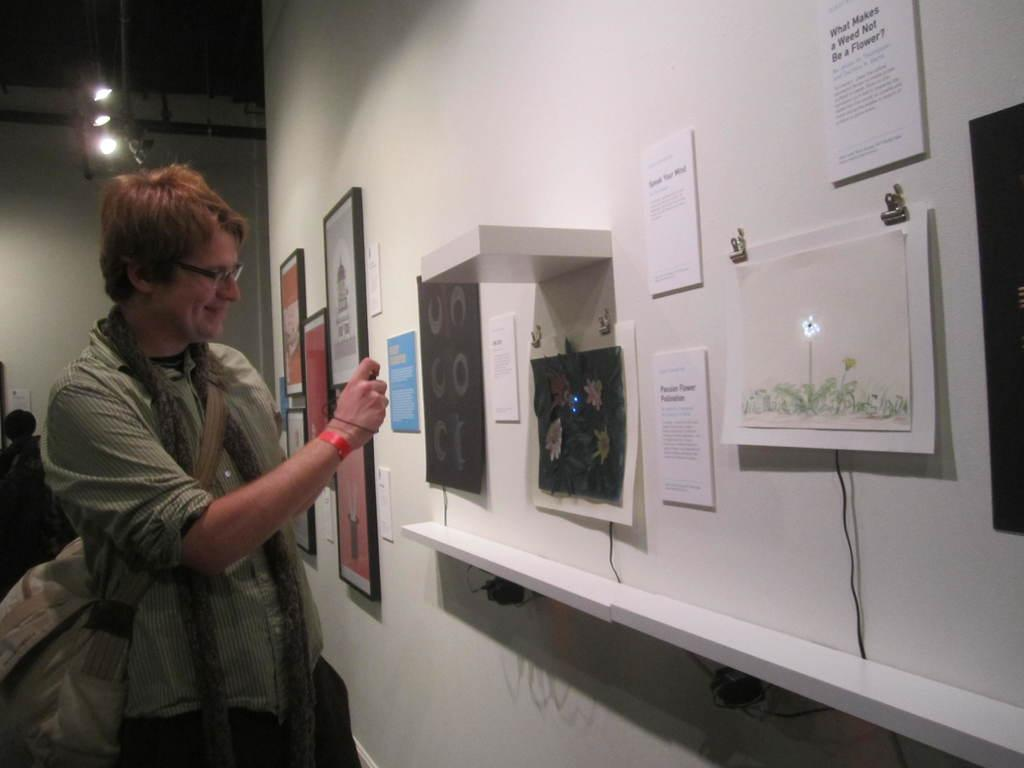What is located on the left side of the image? There is a man and lights on the left side of the image. What can be seen on the right side of the image? There are posters and photo frames on the wall on the right side of the image. What is the educational background of the man in the image? There is no information about the man's educational background provided in the image. What is the aftermath of the event depicted in the image? There is no event depicted in the image, so there is no aftermath to discuss. 